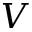Convert formula to latex. <formula><loc_0><loc_0><loc_500><loc_500>V</formula> 